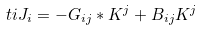Convert formula to latex. <formula><loc_0><loc_0><loc_500><loc_500>\ t i J _ { i } = - G _ { i j } * K ^ { j } + B _ { i j } K ^ { j }</formula> 